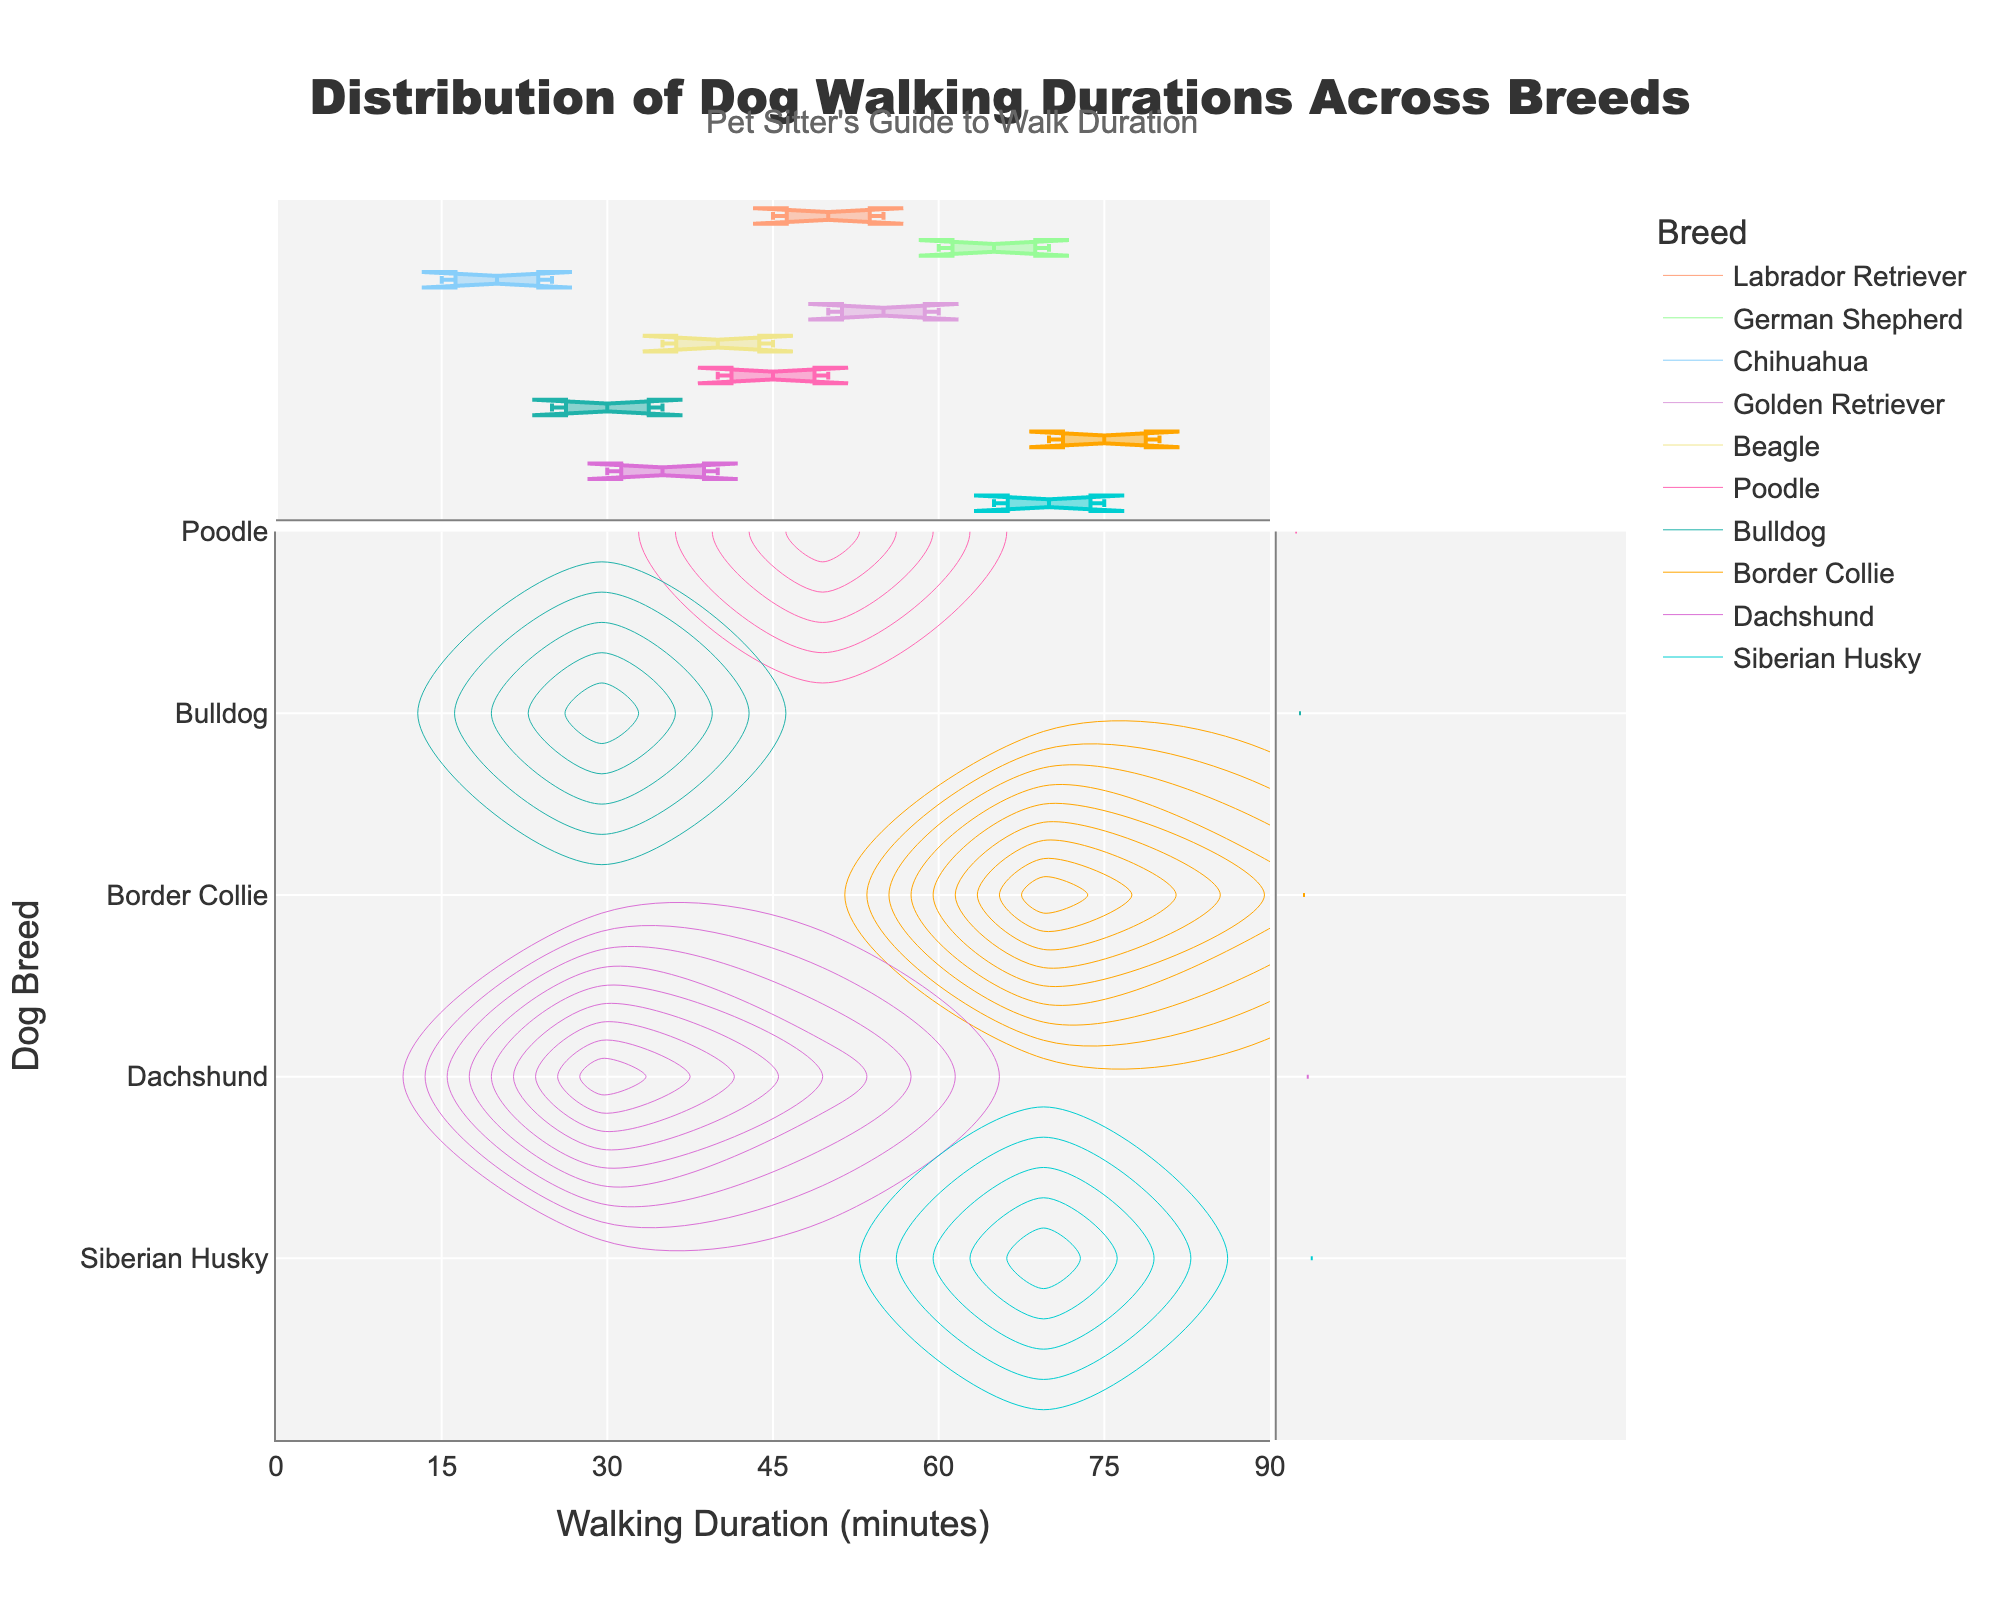What's the title of the plot? The title is usually located at the top of the figure and gives an overview of what the plot represents. In this case, the title is "Distribution of Dog Walking Durations Across Breeds".
Answer: Distribution of Dog Walking Durations Across Breeds What is the x-axis labeled as? The x-axis label is typically found along the horizontal axis of the figure. In this plot, it is labeled "Walking Duration (minutes)".
Answer: Walking Duration (minutes) Which breed has the longest walking duration? Look for the breed whose walking duration distribution reaches the highest value on the x-axis. The Border Collie has a maximum walking duration of 80 minutes.
Answer: Border Collie Which breed has a walking duration that peaks in the shortest time? Identify the breed whose distribution has a peak at the lowest value on the x-axis. The Chihuahua has the shortest walking duration, with a peak around 15-25 minutes.
Answer: Chihuahua What are the walking duration ranges for German Shepherds and Dachshunds? Locate the distributions for German Shepherds and Dachshunds by following the color legend. German Shepherds range from 60 to 70 minutes, and Dachshunds range from 30 to 40 minutes.
Answer: German Shepherds: 60-70 minutes, Dachshunds: 30-40 minutes Which breed has a similar walking duration range to Labrador Retrievers? Compare the distributions of other breeds to the Labrador Retrievers, who range from 45 to 55 minutes. Golden Retrievers have a similar range (50-60 minutes).
Answer: Golden Retrievers Among Beagle, Poodle, and Bulldog, which breed generally requires the longest walking duration? Check the distributions for Beagle, Poodle, and Bulldog. Beagles range from 35 to 45 minutes, Poodles from 40 to 50 minutes, and Bulldogs from 25 to 35 minutes. Poodles generally require the longest walking duration.
Answer: Poodle What walking duration range does the violin plot along the y-axis show for Border Collies? The violin plot in the figure represents the distribution of walking durations for each breed. For Border Collies, the violin plot ranges from 70 to 80 minutes.
Answer: 70-80 minutes Comparing the walking durations of Siberian Huskies and Golden Retrievers, which breed has a higher average duration? Look at the density and distribution peaks. Siberian Huskies range from 65 to 75 minutes, while Golden Retrievers range from 50 to 60 minutes. Siberian Huskies have a higher average walking duration.
Answer: Siberian Huskies 